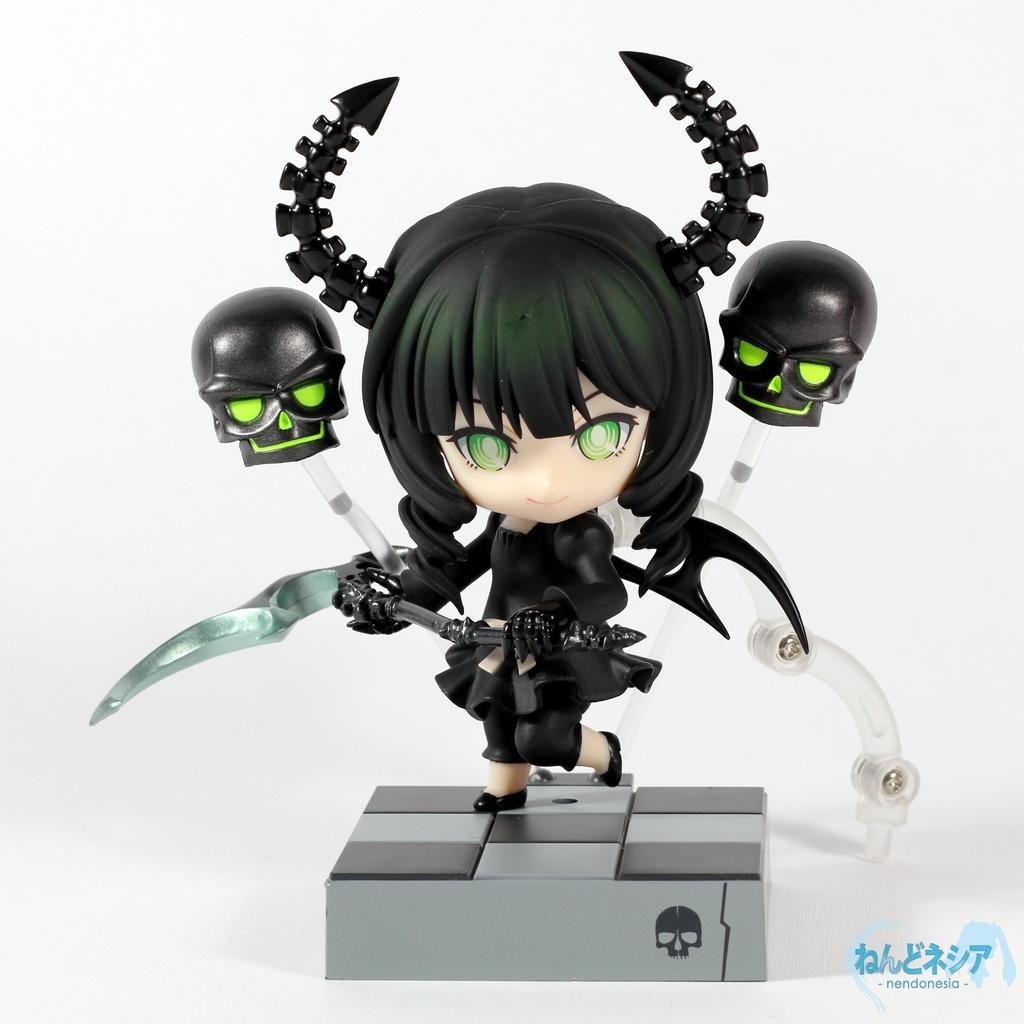What type of image is depicted in the picture? There is a cartoon animated image in the picture. What is the character wearing in the image? The character is wearing a black dress. What is the character holding in their hands? The character is holding a weapon in their hands. What is the character standing on in the image? The character is standing on a surface. How many clocks can be seen on the character's shoes in the image? There are no shoes or clocks present in the image; it features a cartoon character wearing a black dress and holding a weapon. What type of insect is crawling on the character's weapon in the image? There are no insects present in the image; it only features the character, their clothing, and the weapon they are holding. 